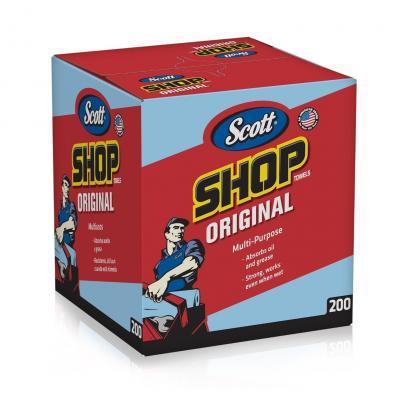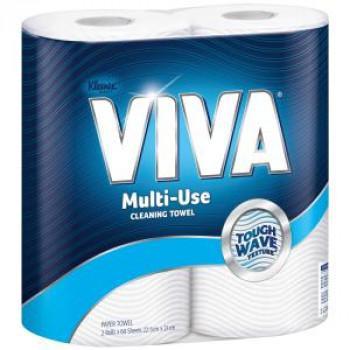The first image is the image on the left, the second image is the image on the right. Given the left and right images, does the statement "In at least one image there is a 6 pack of scott paper towel sitting on a store shelve in mostly red packaging." hold true? Answer yes or no. No. The first image is the image on the left, the second image is the image on the right. For the images shown, is this caption "The right image shows multipacks of paper towels on a store shelf, and includes a pack with the bottom half red." true? Answer yes or no. No. 